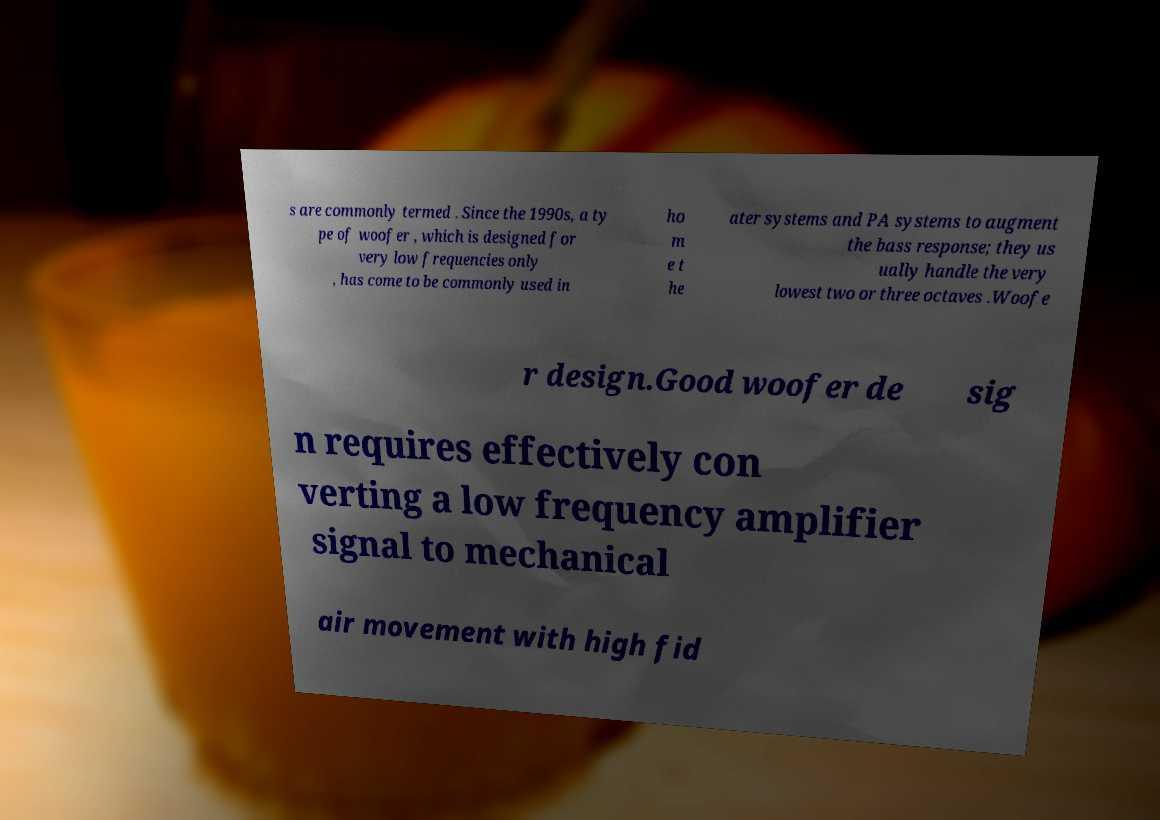What messages or text are displayed in this image? I need them in a readable, typed format. s are commonly termed . Since the 1990s, a ty pe of woofer , which is designed for very low frequencies only , has come to be commonly used in ho m e t he ater systems and PA systems to augment the bass response; they us ually handle the very lowest two or three octaves .Woofe r design.Good woofer de sig n requires effectively con verting a low frequency amplifier signal to mechanical air movement with high fid 